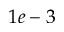Convert formula to latex. <formula><loc_0><loc_0><loc_500><loc_500>1 e - 3</formula> 